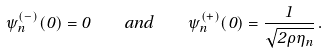Convert formula to latex. <formula><loc_0><loc_0><loc_500><loc_500>\psi _ { n } ^ { ( - ) } ( 0 ) = 0 \quad a n d \quad \psi _ { n } ^ { ( + ) } ( 0 ) = \frac { 1 } { \sqrt { 2 \rho \eta _ { n } } } \, .</formula> 